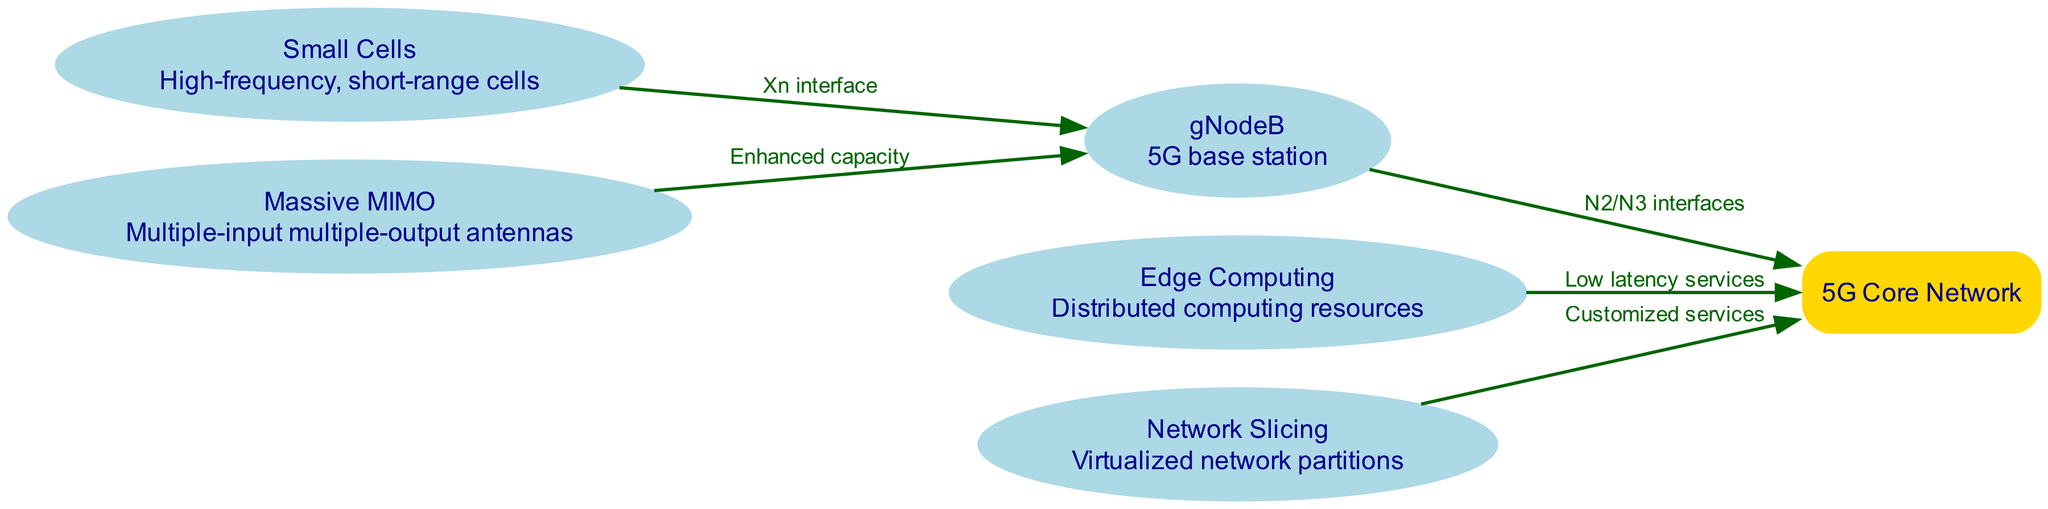What is the central node in the diagram? The central node is explicitly labeled in the diagram as the "5G Core Network". This is usually indicated with a different shape or color, making it stand out among the other nodes.
Answer: 5G Core Network How many orbiting nodes are there in the diagram? The diagram lists five orbiting nodes, named gNodeB, Small Cells, Massive MIMO, Edge Computing, and Network Slicing. This can be counted directly from the provided list of nodes.
Answer: 5 What is the description of the "Small Cells"? The description is provided right next to the node in the diagram. It states that Small Cells are "High-frequency, short-range cells," which gives a clear understanding of their role.
Answer: High-frequency, short-range cells Which node provides low latency services? The edge computing node is identified as providing low latency services as indicated by the connection labeled "Low latency services" pointing to the 5G Core Network.
Answer: Edge Computing What type of connection exists between "Massive MIMO" and "gNodeB"? The connection type is explicitly labeled as "Enhanced capacity" in the diagram, representing the functionality of the link between these two nodes.
Answer: Enhanced capacity How is "Network Slicing" connected to the "5G Core Network"? The diagram shows a direct connection from "Network Slicing" to "5G Core Network", labeled with "Customized services," indicating a specific purpose for this connection.
Answer: Customized services What is the role of gNodeB in the diagram? The gNodeB is described as a "5G base station," which highlights its essential function within the network architecture. This information is directly stated in the diagram.
Answer: 5G base station What do the N2/N3 interfaces represent in the diagram? The N2/N3 interfaces function as a connection from gNodeB to the 5G Core Network. This indicate a specific protocol or interface type used for communication between these nodes.
Answer: N2/N3 interfaces Describe the purpose of "Edge Computing" as depicted in the diagram. The diagram indicates that Edge Computing provides "Distributed computing resources," which shows its role in enhancing the network's efficiency by processing data closer to the source.
Answer: Distributed computing resources 